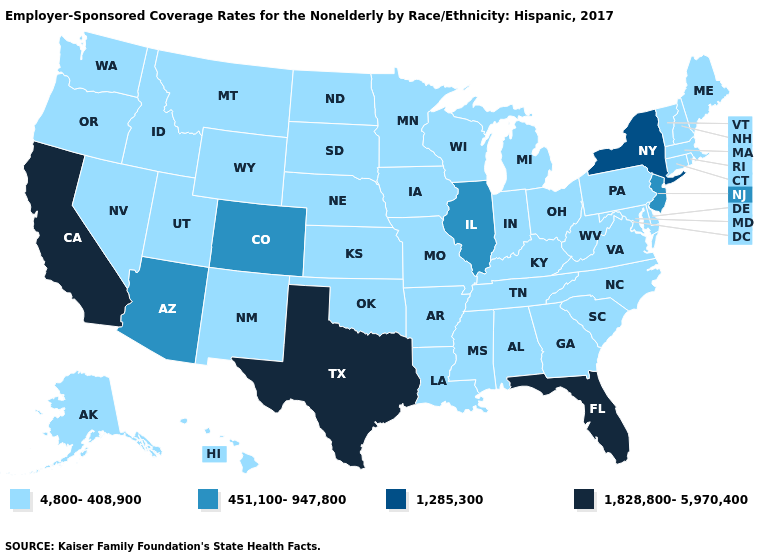What is the value of Michigan?
Give a very brief answer. 4,800-408,900. Does Massachusetts have the same value as New Jersey?
Write a very short answer. No. What is the value of Iowa?
Short answer required. 4,800-408,900. Which states hav the highest value in the MidWest?
Keep it brief. Illinois. What is the value of Massachusetts?
Short answer required. 4,800-408,900. Does Arkansas have the lowest value in the South?
Quick response, please. Yes. Which states hav the highest value in the West?
Write a very short answer. California. What is the value of Minnesota?
Quick response, please. 4,800-408,900. Does Maryland have a higher value than Georgia?
Write a very short answer. No. What is the value of West Virginia?
Short answer required. 4,800-408,900. What is the highest value in the USA?
Give a very brief answer. 1,828,800-5,970,400. Does Arkansas have the highest value in the South?
Be succinct. No. What is the value of Hawaii?
Concise answer only. 4,800-408,900. What is the value of Illinois?
Give a very brief answer. 451,100-947,800. How many symbols are there in the legend?
Answer briefly. 4. 